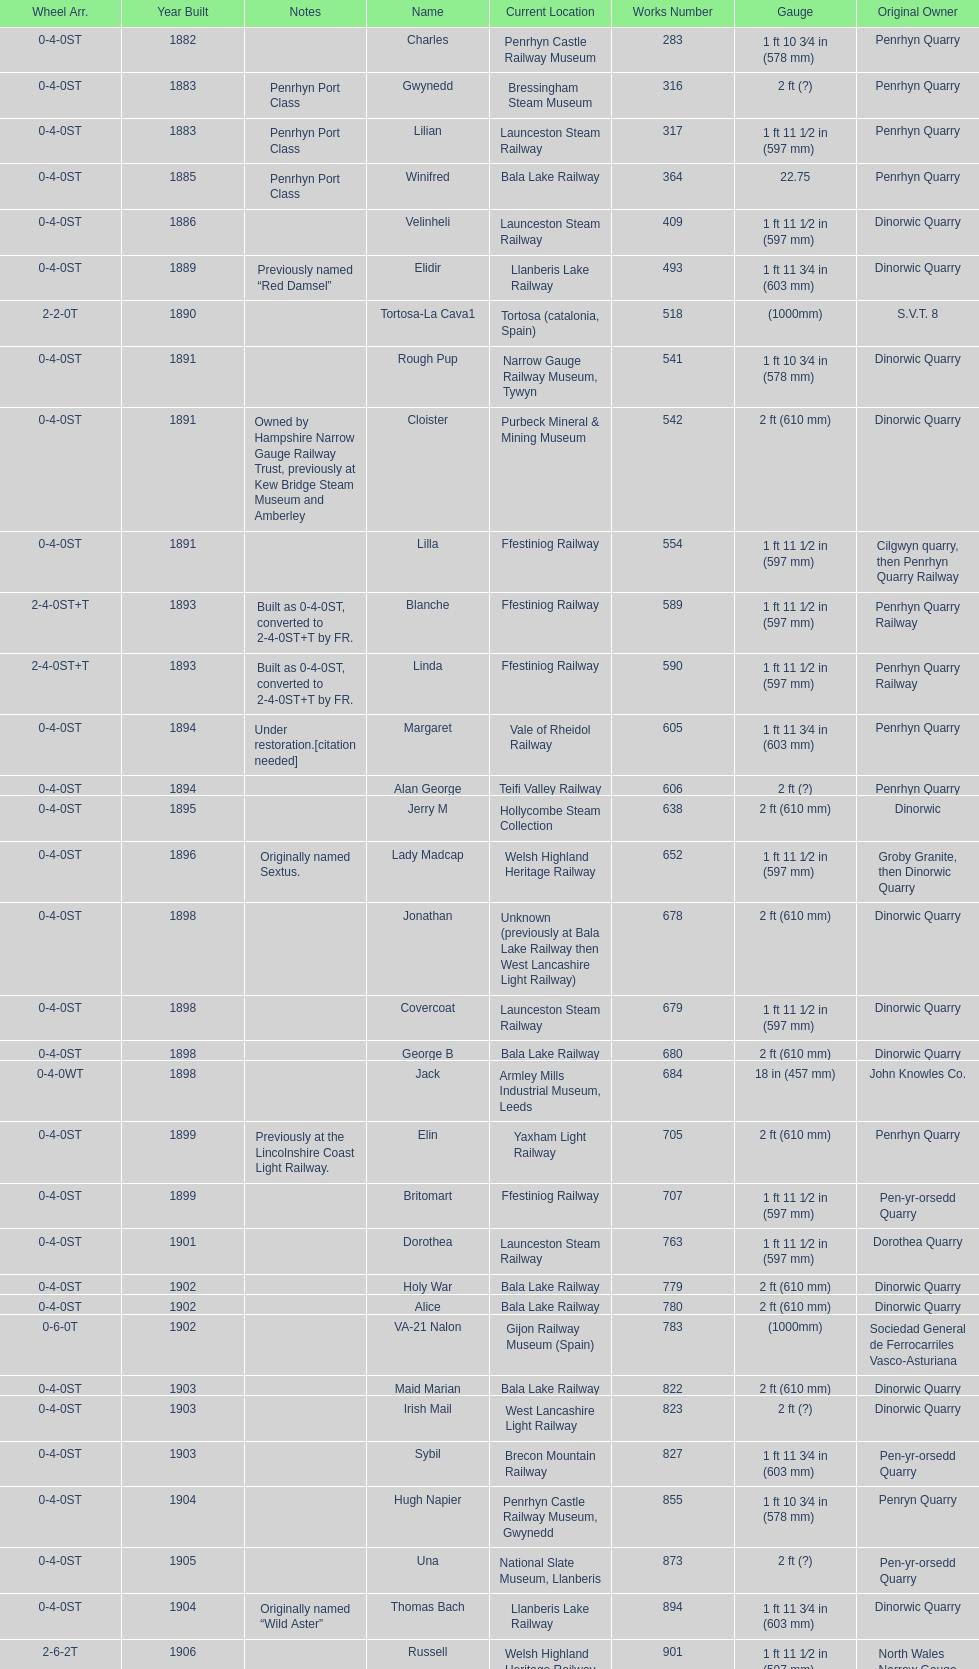Which works number had a larger gauge, 283 or 317? 317. 